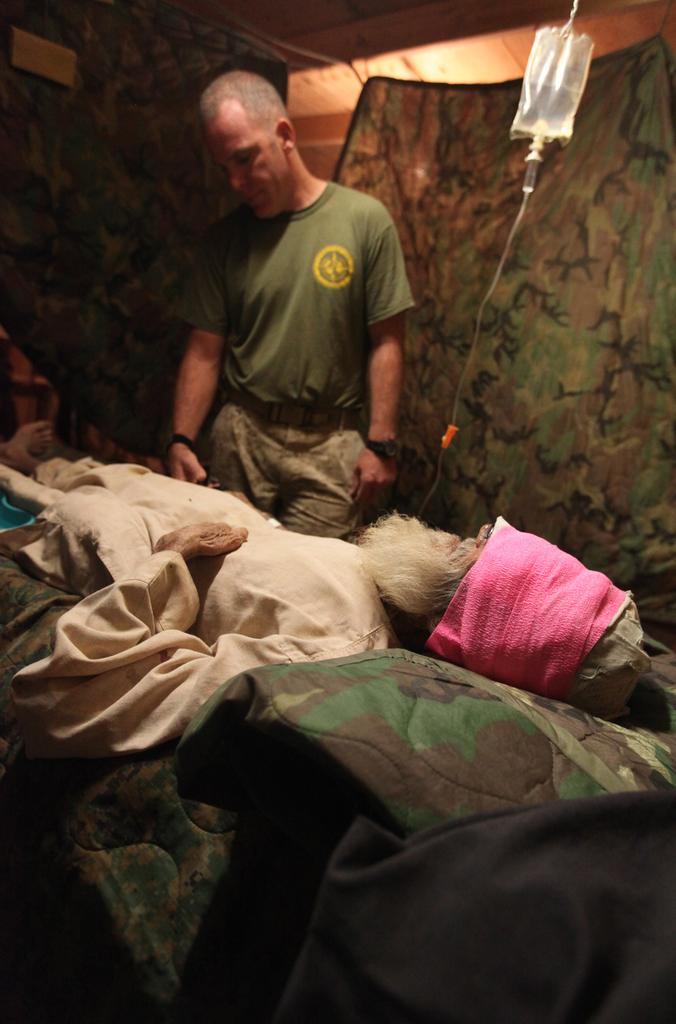What is the position of the person in the image? There is a person lying on the bed in the image. Is there another person in the image? Yes, there is a person standing behind the bed in the image. What is the standing person wearing? The standing person is wearing a green T-shirt. What can be seen hanging to the right of the bed? A saline packet is hanging to the right of the bed. What is visible in the background of the image? There are curtains in the background of the image. What type of jelly can be seen on the guitar in the image? There is no guitar or jelly present in the image. Can you tell me how many streets are visible in the image? There are no streets visible in the image. 